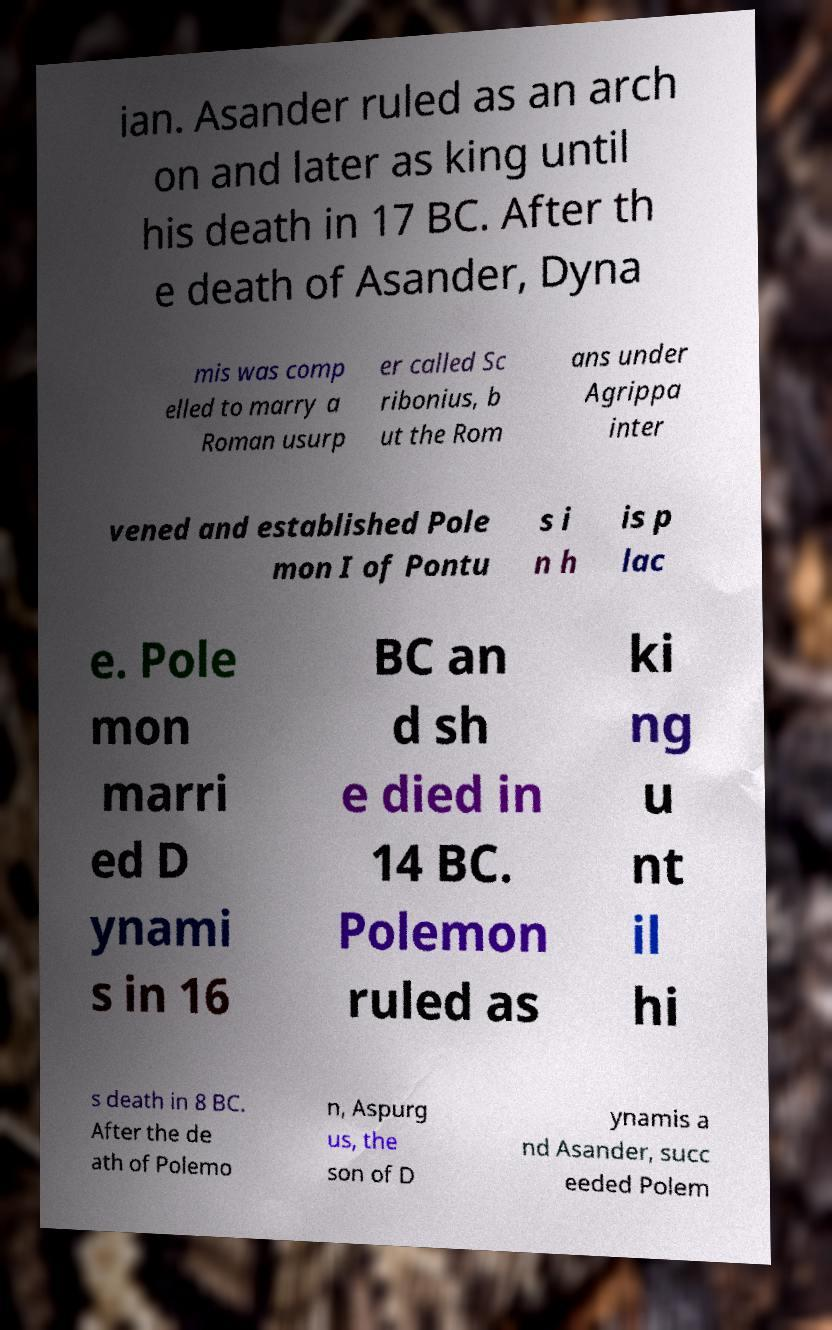Could you extract and type out the text from this image? ian. Asander ruled as an arch on and later as king until his death in 17 BC. After th e death of Asander, Dyna mis was comp elled to marry a Roman usurp er called Sc ribonius, b ut the Rom ans under Agrippa inter vened and established Pole mon I of Pontu s i n h is p lac e. Pole mon marri ed D ynami s in 16 BC an d sh e died in 14 BC. Polemon ruled as ki ng u nt il hi s death in 8 BC. After the de ath of Polemo n, Aspurg us, the son of D ynamis a nd Asander, succ eeded Polem 